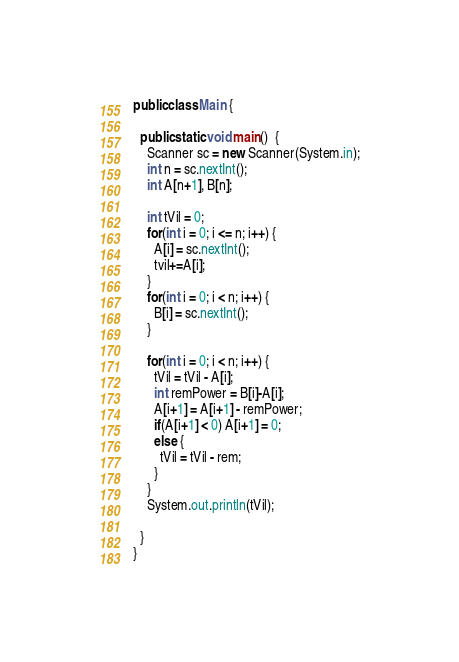<code> <loc_0><loc_0><loc_500><loc_500><_Java_>public class Main {
  
  public static void main()  {
    Scanner sc = new Scanner(System.in);
    int n = sc.nextInt();
    int A[n+1], B[n];
    
    int tVil = 0;
    for(int i = 0; i <= n; i++) {
      A[i] = sc.nextInt();
      tvil+=A[i];
    }
    for(int i = 0; i < n; i++) {
      B[i] = sc.nextInt();
    }
    
    for(int i = 0; i < n; i++) {
      tVil = tVil - A[i];
      int remPower = B[i]-A[i];
      A[i+1] = A[i+1] - remPower;
      if(A[i+1] < 0) A[i+1] = 0;
      else {
        tVil = tVil - rem;
      }
    }
    System.out.println(tVil);
    
  }
}</code> 